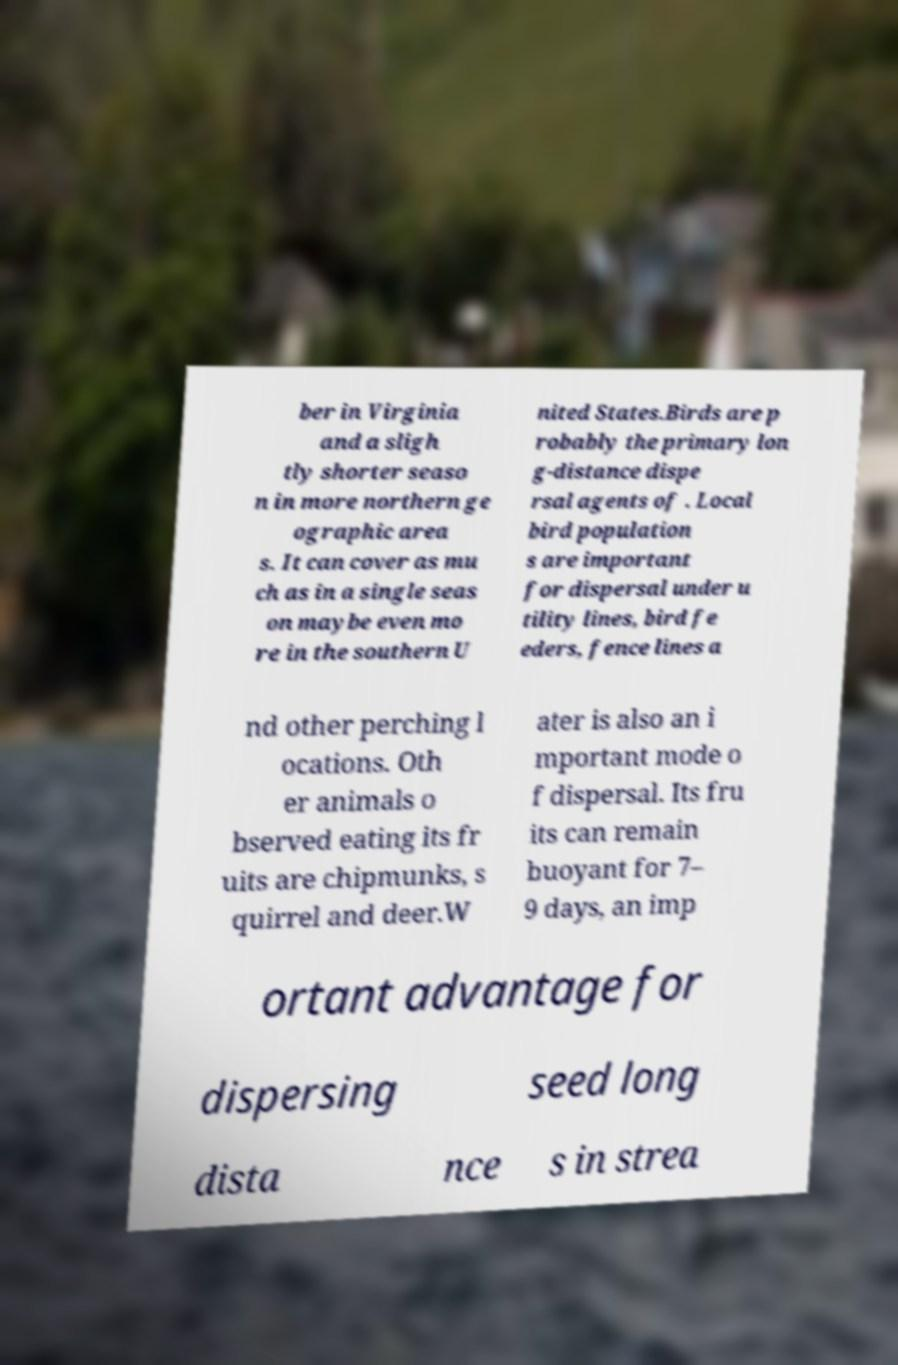There's text embedded in this image that I need extracted. Can you transcribe it verbatim? ber in Virginia and a sligh tly shorter seaso n in more northern ge ographic area s. It can cover as mu ch as in a single seas on maybe even mo re in the southern U nited States.Birds are p robably the primary lon g-distance dispe rsal agents of . Local bird population s are important for dispersal under u tility lines, bird fe eders, fence lines a nd other perching l ocations. Oth er animals o bserved eating its fr uits are chipmunks, s quirrel and deer.W ater is also an i mportant mode o f dispersal. Its fru its can remain buoyant for 7– 9 days, an imp ortant advantage for dispersing seed long dista nce s in strea 